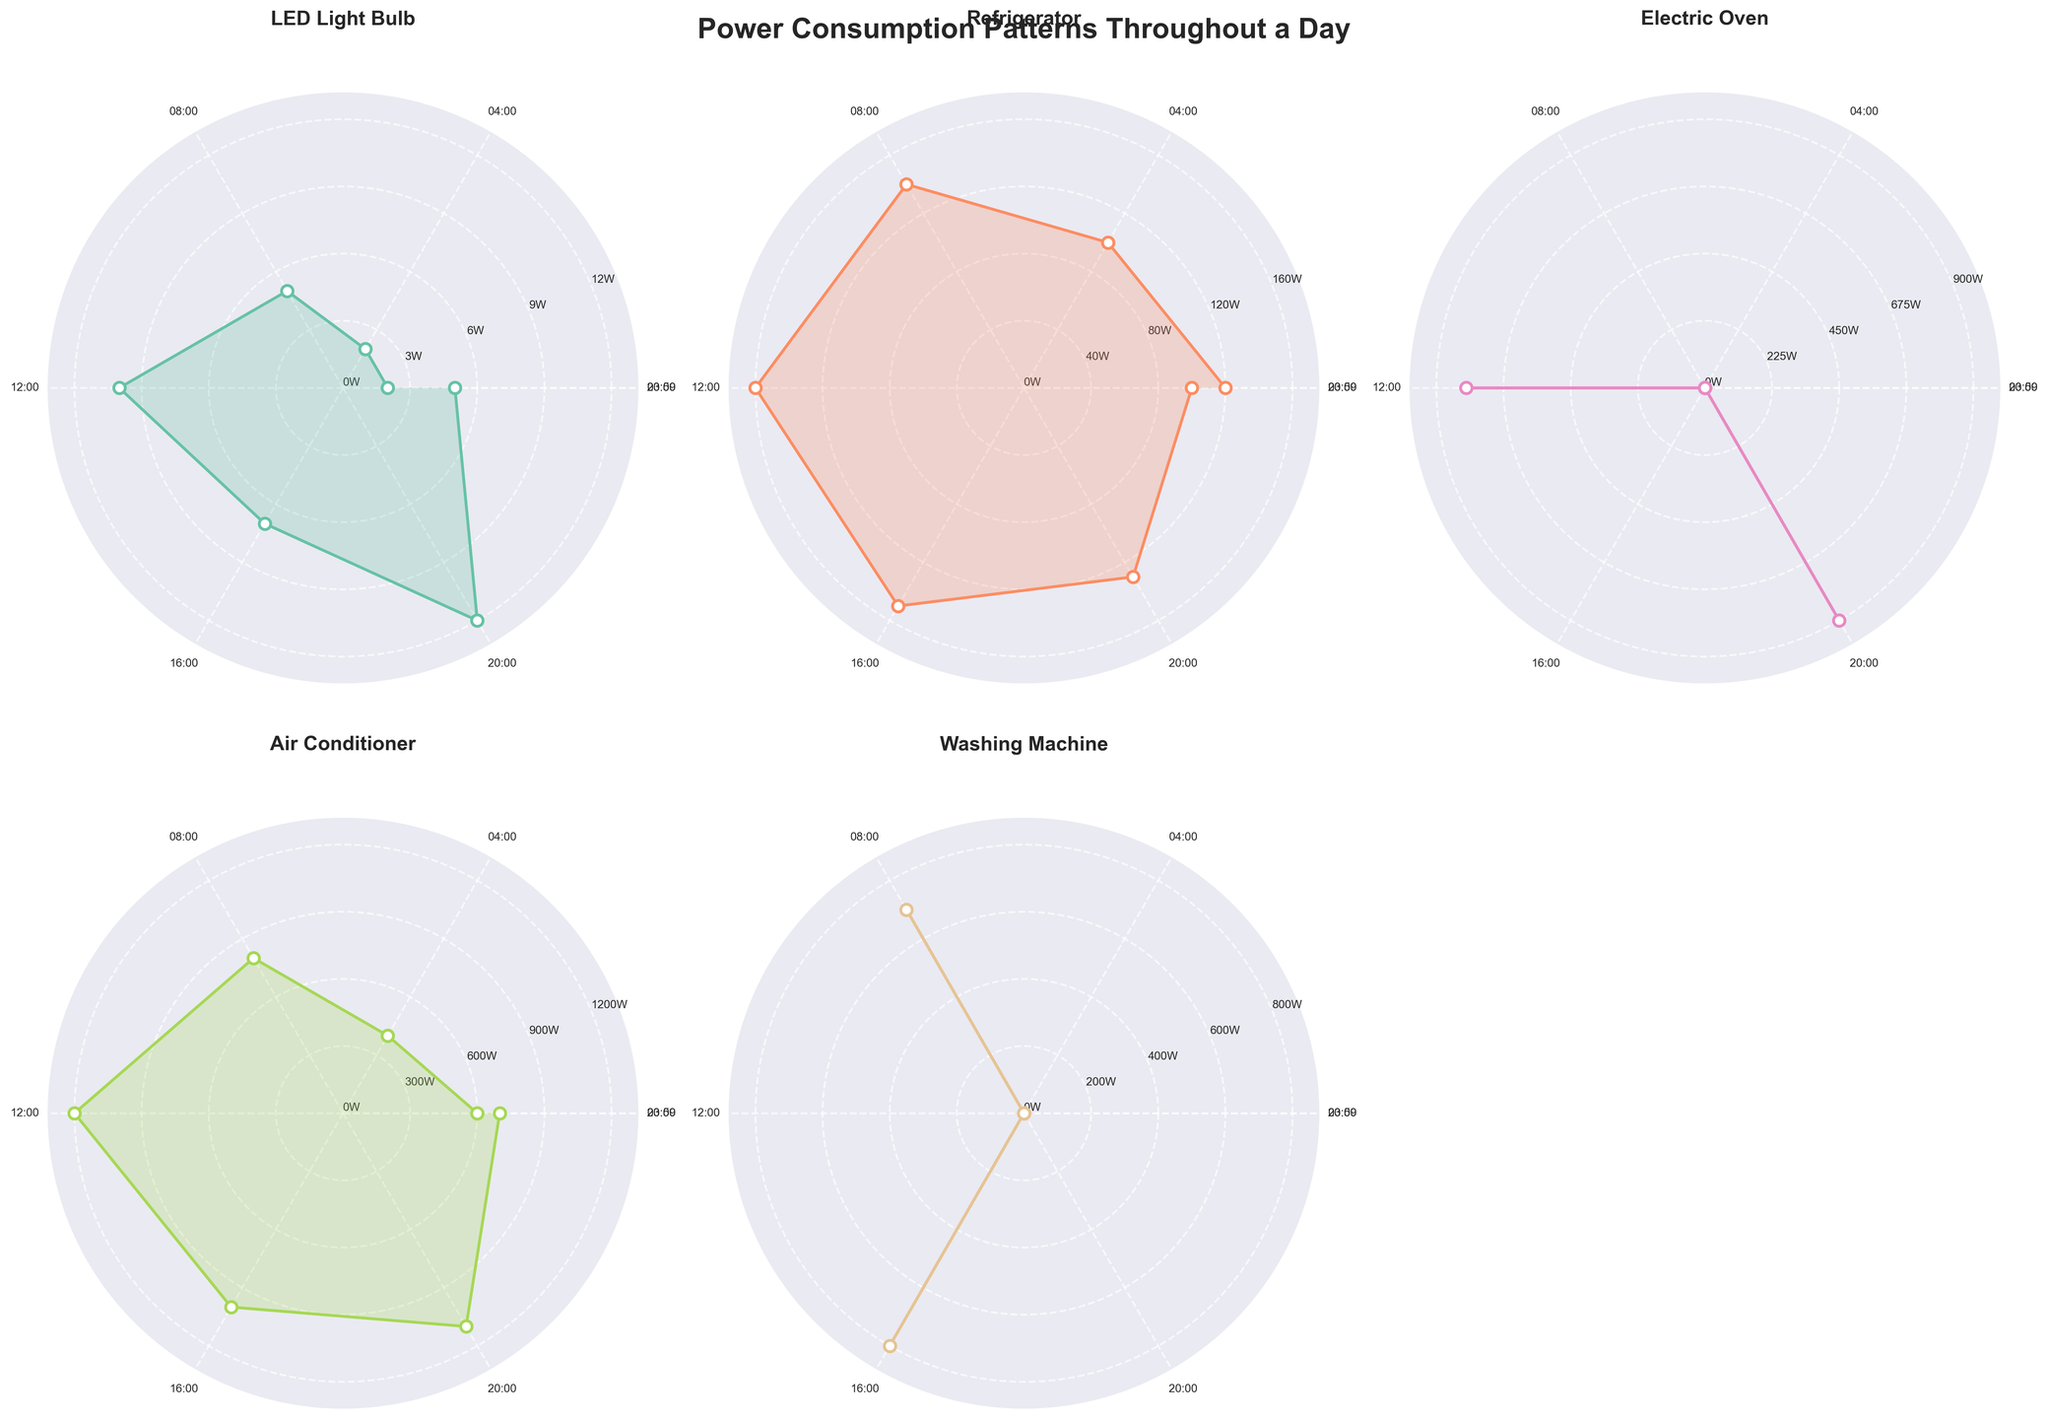What is the peak power consumption for the LED Light Bulb throughout the day? The highest point on the polar plot for the LED Light Bulb's power consumption indicates the peak consumption. Referring to the visual presentation, we see the peak power consumption occurs at 20:00 with a value of 12 Watts.
Answer: 12 Watts Which device shows the most consistent power consumption throughout the day? By observing the polar plots, the Refrigerator shows the most consistent power consumption throughout the day with relatively smaller fluctuations compared to other devices. The variations in power consumption are minimal from 100 Watts to 160 Watts.
Answer: Refrigerator At what times does the Electric Oven show any power consumption? Checking the Electric Oven's polar chart, power consumption is indicated by points at 12:00 and 20:00. These are the only times when the electric oven consumes power, shown as peaks at these times.
Answer: 12:00 and 20:00 How does the power consumption of the Air Conditioner at 16:00 compare to Washing Machine at the same time? At 16:00, the Air Conditioner’s consumption is higher, as seen in its plot reaching approximately 1000 Watts, while the Washing Machine draws about 800 Watts, demonstrating its lower consumption.
Answer: Air Conditioner higher What's the average power consumption for the Washing Machine throughout the day? Summing up the Washing Machine’s power consumptions (0 + 0 + 700 + 0 + 800 + 0 + 0) and dividing by the 7 data points gives: (0 + 0 + 700 + 0 + 800 + 0 + 0) / 7 = 150 Watts.
Answer: 150 Watts Which device experiences the largest fluctuation in power consumption, and what is the range from the minimum to maximum? The Air Conditioner experiences the largest fluctuation, with its minimum power consumption at 04:00 (400 Watts) and maximum at 12:00 (1200 Watts). The range calculation is 1200 - 400 = 800 Watts.
Answer: Air Conditioner, 800 Watts When does the Refrigerator reach its peak power consumption, and what is the value? The Refrigerator reaches its peak power consumption at 12:00. This is identified in the polar chart as the highest point, with a value of 160 Watts.
Answer: 12:00, 160 Watts Would you expect an increase in LED Light Bulb power consumption at night compared to during the day? Yes, the polar chart indicates an increase in power consumption for the LED Light Bulb during the night hours, peaking around 20:00 at 12 Watts and remaining relatively higher compared to daytime.
Answer: Yes 